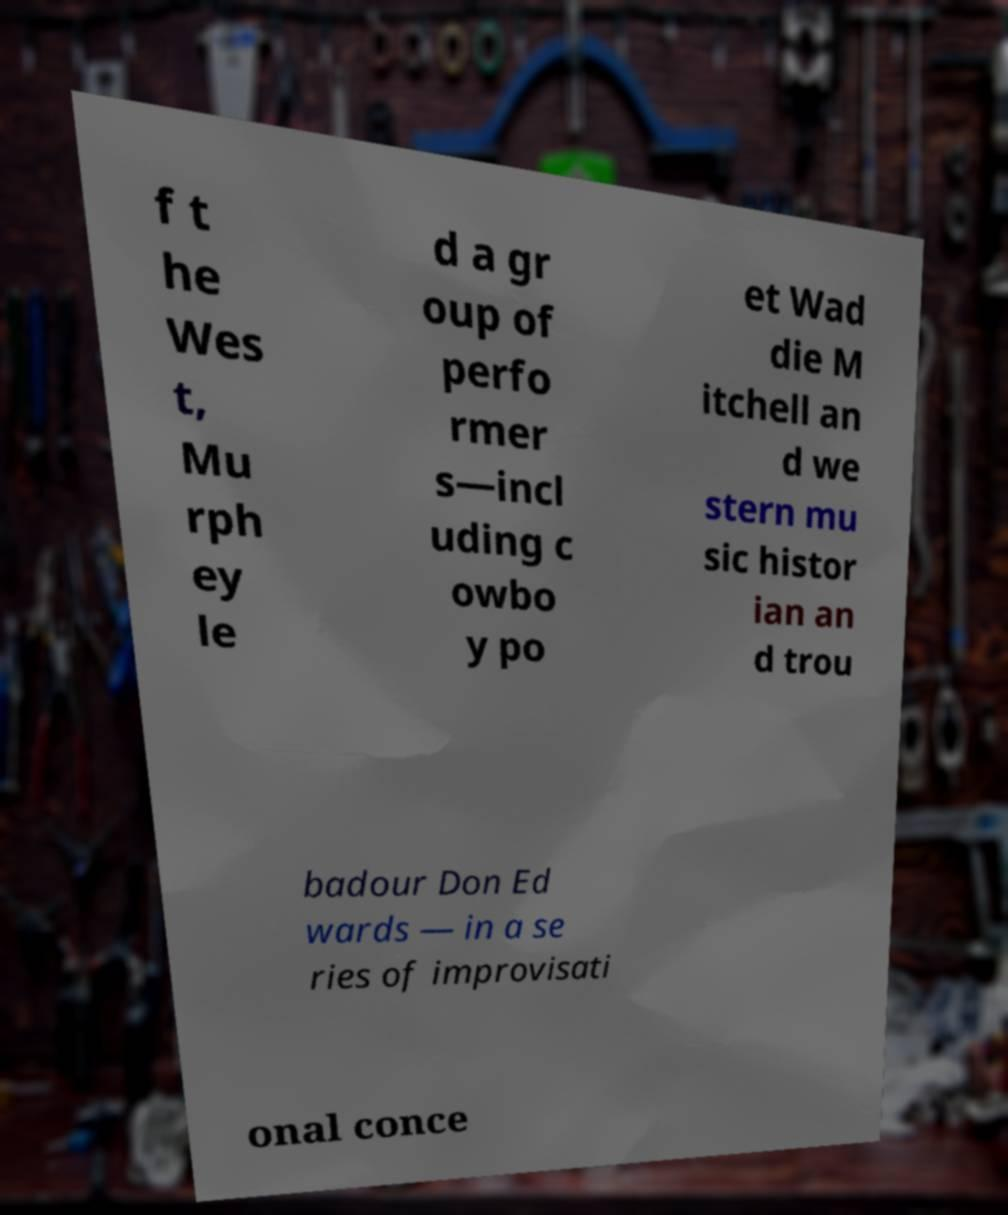Please read and relay the text visible in this image. What does it say? f t he Wes t, Mu rph ey le d a gr oup of perfo rmer s—incl uding c owbo y po et Wad die M itchell an d we stern mu sic histor ian an d trou badour Don Ed wards — in a se ries of improvisati onal conce 